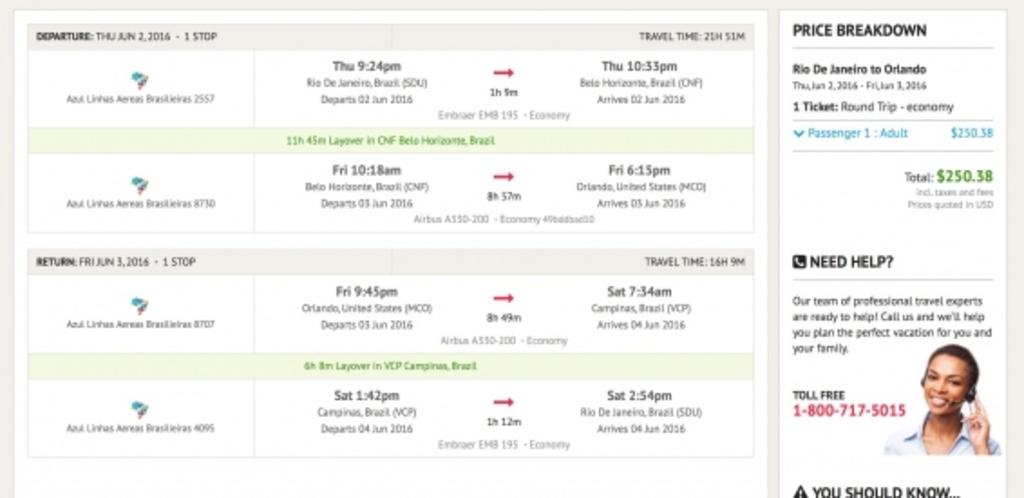What type of image is shown in the screenshot? The screenshot contains an image. What else is present in the screenshot besides the image? The screenshot contains text. Can you see any flowers in the image shown in the screenshot? There are no flowers visible in the image shown in the screenshot. Is there a robin bird present in the image shown in the screenshot? There is no robin bird present in the image shown in the screenshot. 